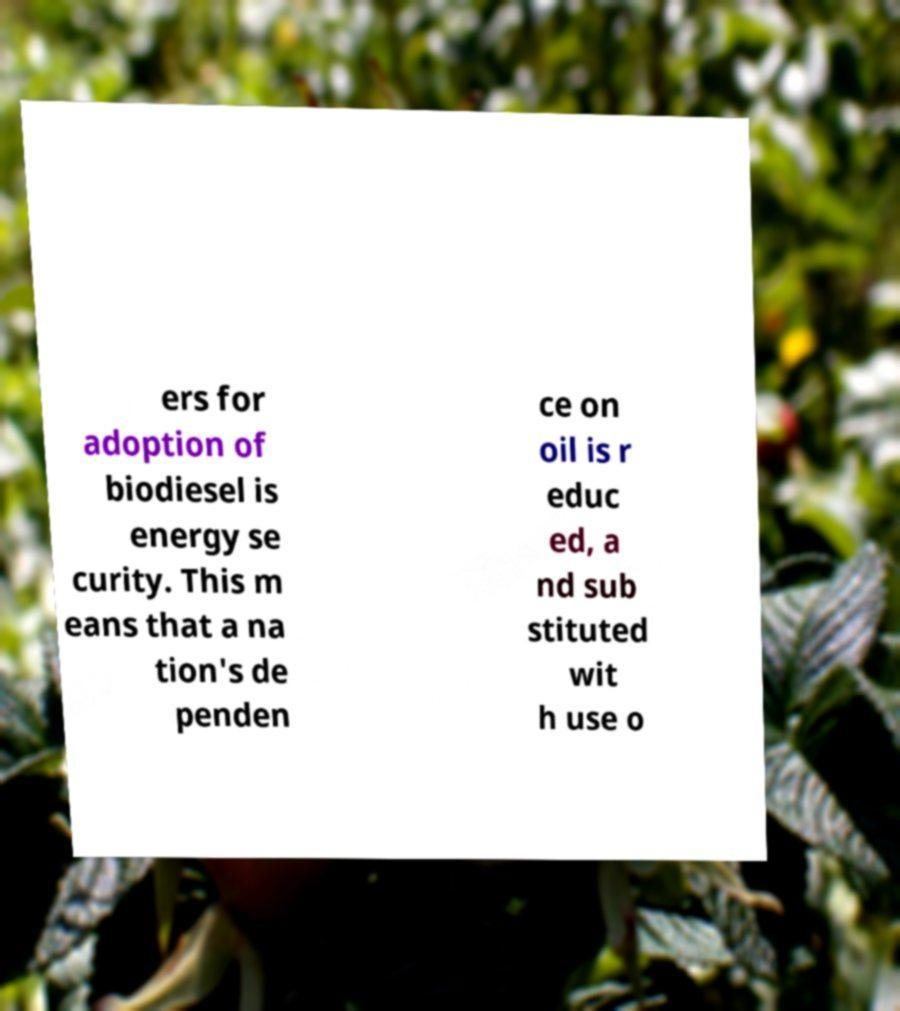What messages or text are displayed in this image? I need them in a readable, typed format. ers for adoption of biodiesel is energy se curity. This m eans that a na tion's de penden ce on oil is r educ ed, a nd sub stituted wit h use o 